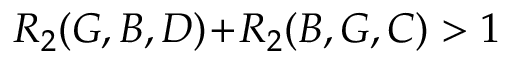Convert formula to latex. <formula><loc_0><loc_0><loc_500><loc_500>R _ { 2 } ( G , B , D ) \, + \, R _ { 2 } ( B , G , C ) > 1</formula> 